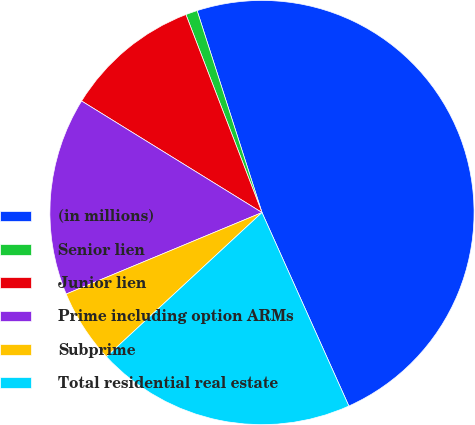<chart> <loc_0><loc_0><loc_500><loc_500><pie_chart><fcel>(in millions)<fcel>Senior lien<fcel>Junior lien<fcel>Prime including option ARMs<fcel>Subprime<fcel>Total residential real estate<nl><fcel>48.23%<fcel>0.89%<fcel>10.35%<fcel>15.09%<fcel>5.62%<fcel>19.82%<nl></chart> 